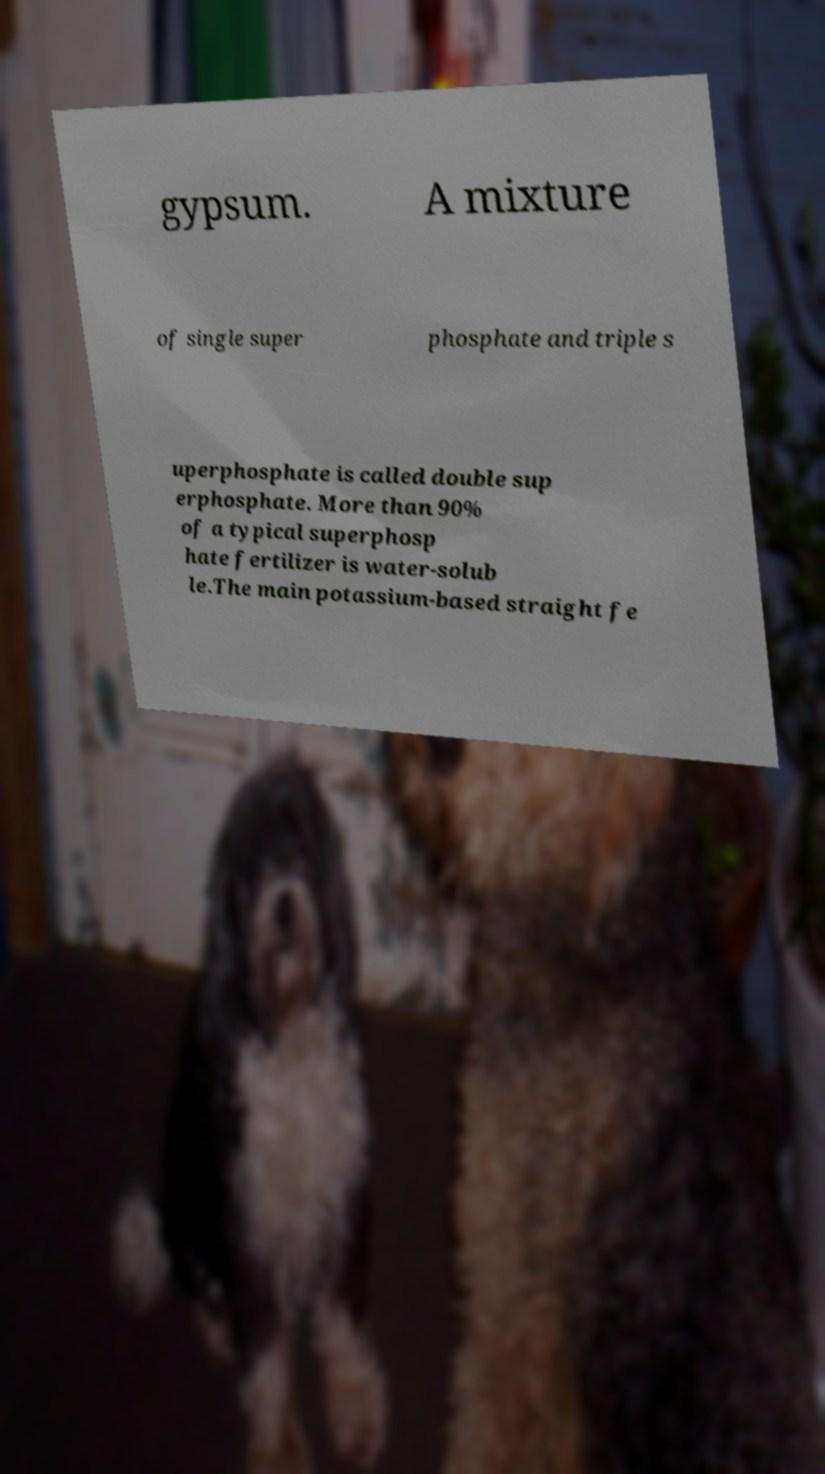I need the written content from this picture converted into text. Can you do that? gypsum. A mixture of single super phosphate and triple s uperphosphate is called double sup erphosphate. More than 90% of a typical superphosp hate fertilizer is water-solub le.The main potassium-based straight fe 